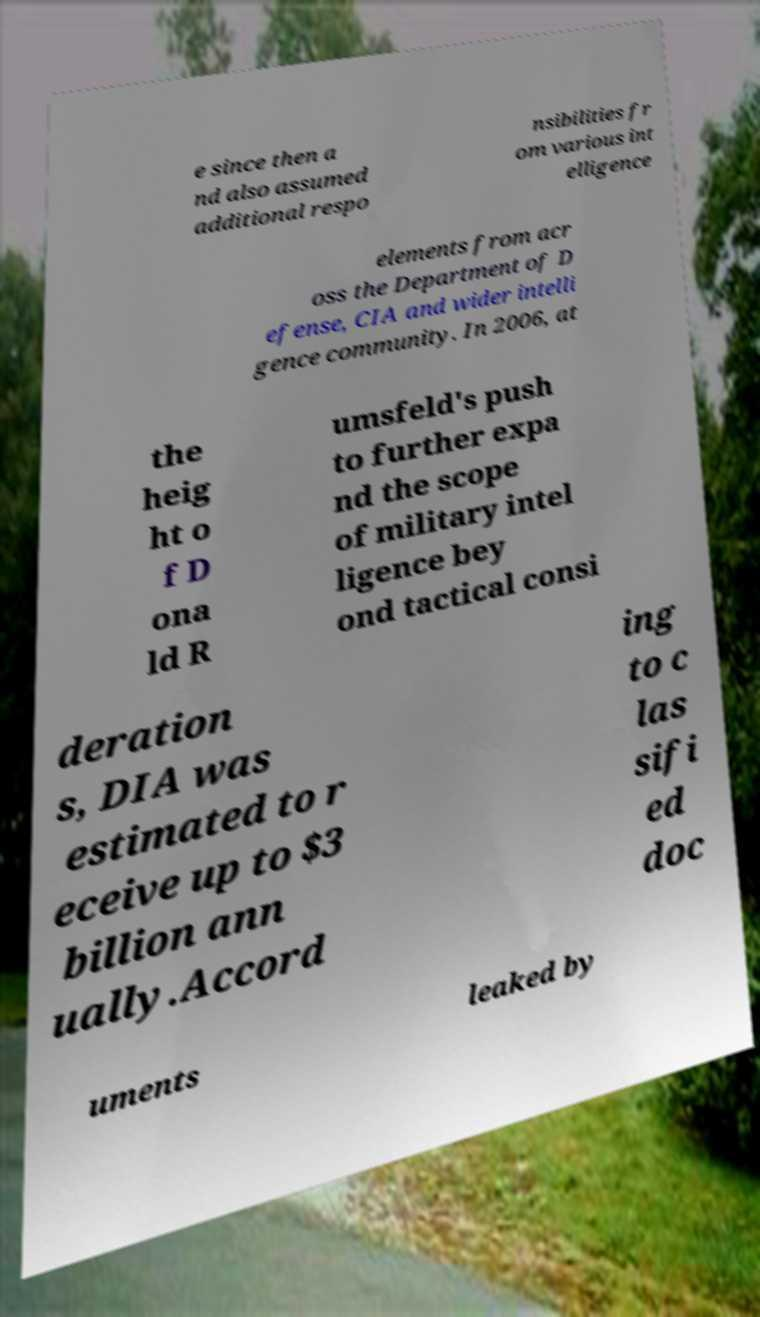For documentation purposes, I need the text within this image transcribed. Could you provide that? e since then a nd also assumed additional respo nsibilities fr om various int elligence elements from acr oss the Department of D efense, CIA and wider intelli gence community. In 2006, at the heig ht o f D ona ld R umsfeld's push to further expa nd the scope of military intel ligence bey ond tactical consi deration s, DIA was estimated to r eceive up to $3 billion ann ually.Accord ing to c las sifi ed doc uments leaked by 